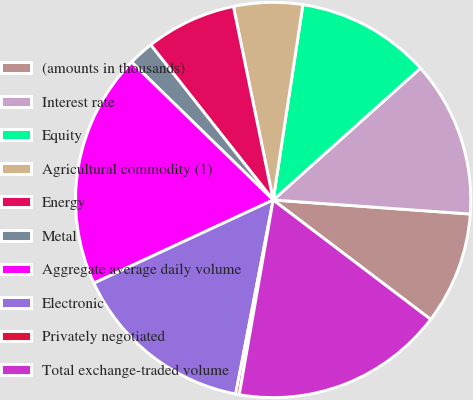Convert chart. <chart><loc_0><loc_0><loc_500><loc_500><pie_chart><fcel>(amounts in thousands)<fcel>Interest rate<fcel>Equity<fcel>Agricultural commodity (1)<fcel>Energy<fcel>Metal<fcel>Aggregate average daily volume<fcel>Electronic<fcel>Privately negotiated<fcel>Total exchange-traded volume<nl><fcel>9.19%<fcel>12.75%<fcel>10.97%<fcel>5.63%<fcel>7.41%<fcel>2.07%<fcel>19.2%<fcel>15.05%<fcel>0.29%<fcel>17.42%<nl></chart> 